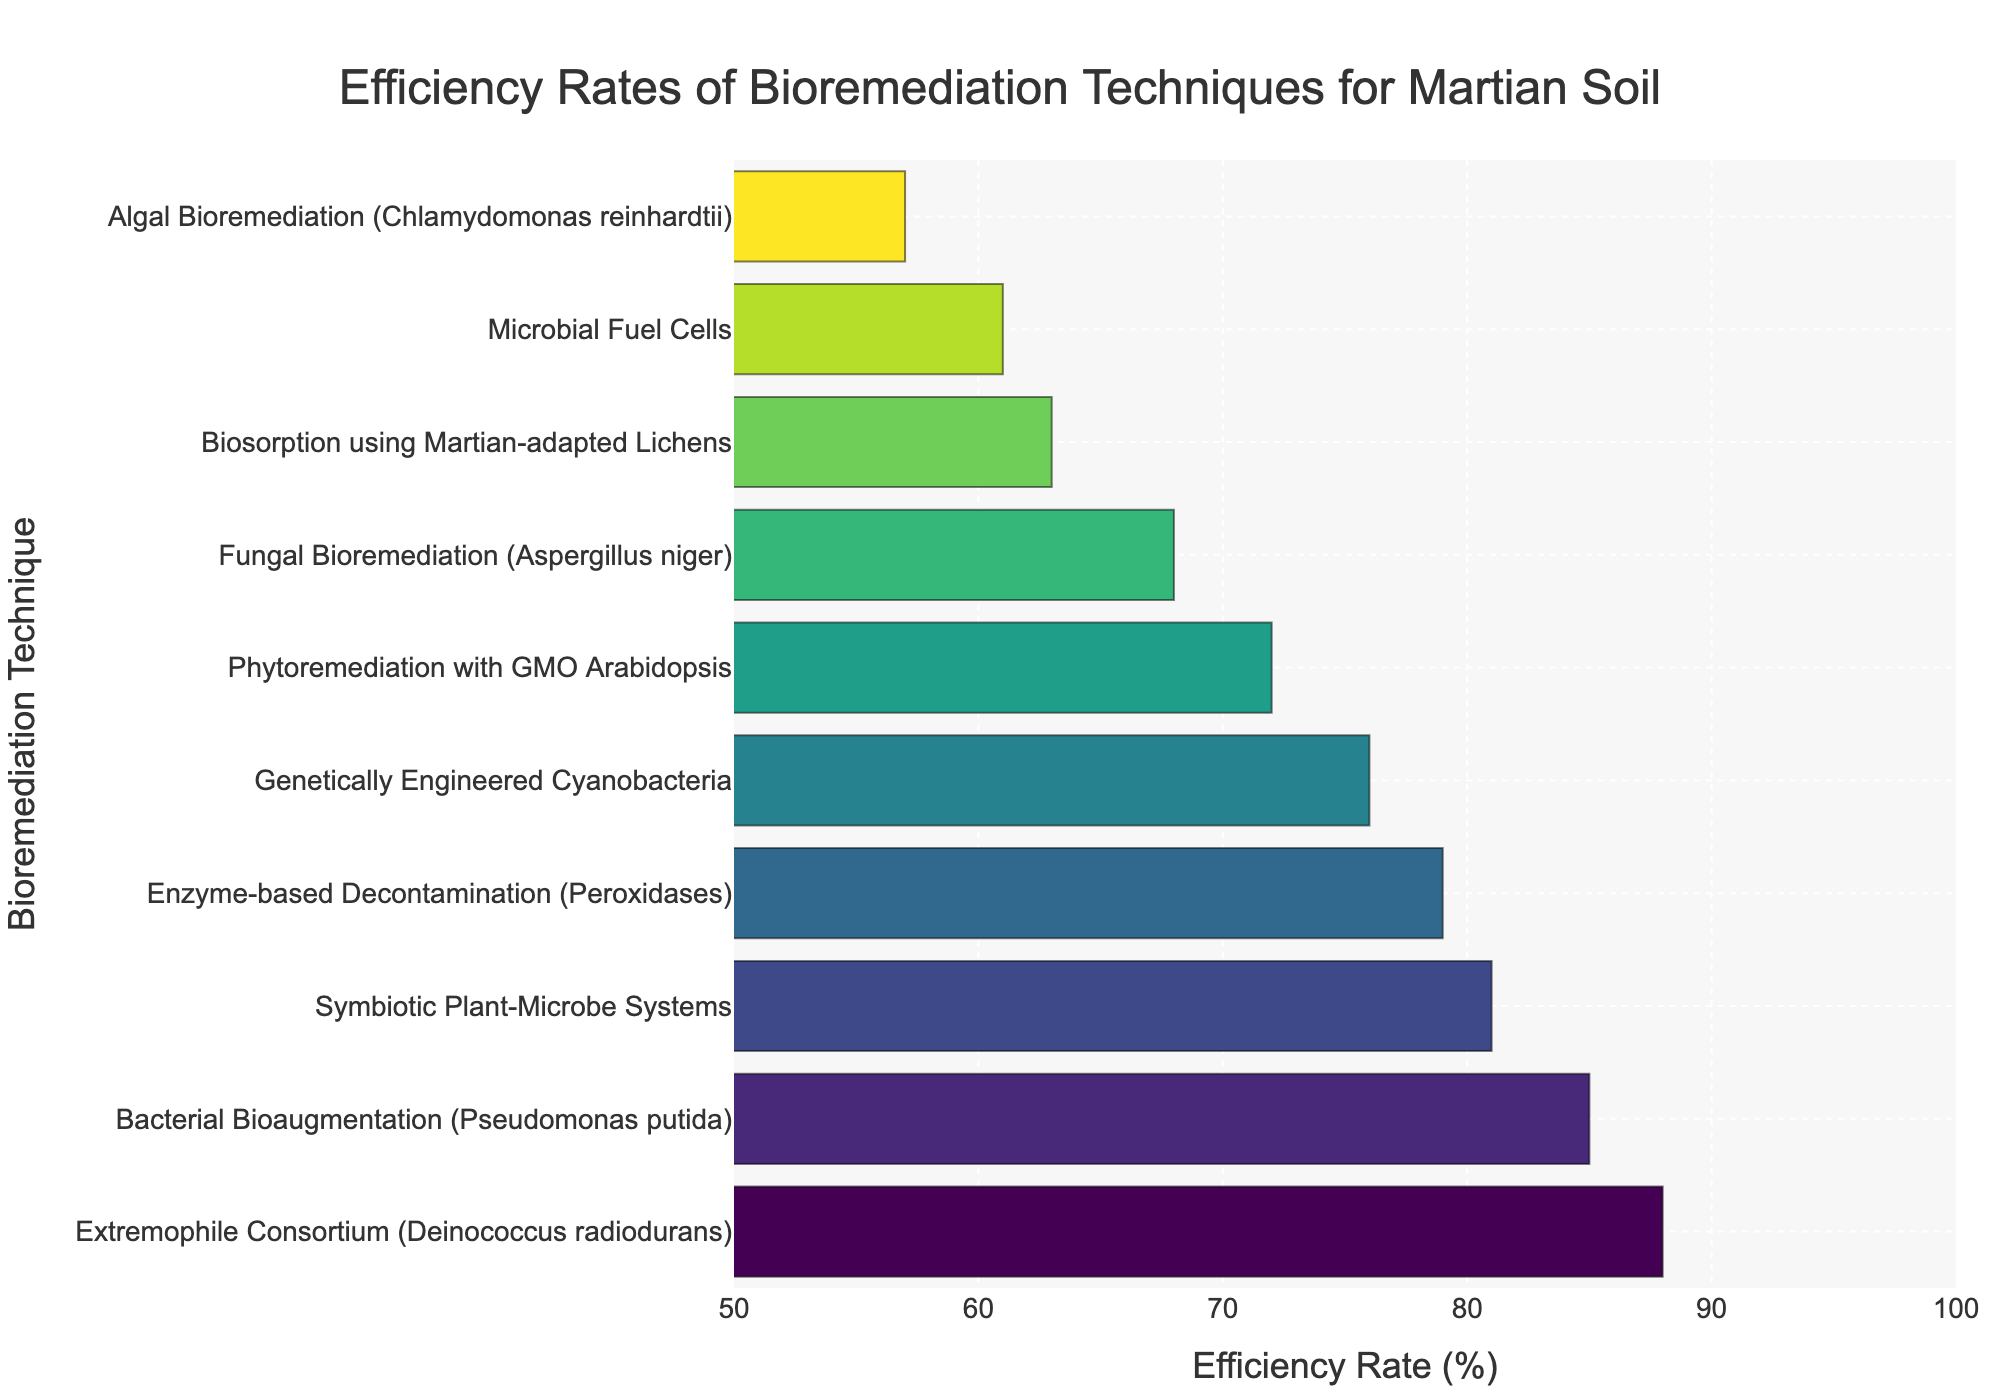What's the highest efficiency rate among the bioremediation techniques? The highest bar on the chart represents the Extremophile Consortium (Deinococcus radiodurans), which has an efficiency rate of 88%. We can clearly see it's the tallest bar, indicating the highest value.
Answer: 88% Which technique has the lowest efficiency rate? The shortest bar on the chart corresponds to Algal Bioremediation (Chlamydomonas reinhardtii), indicating it has the lowest efficiency rate. Looking at the value, we can see it’s 57%.
Answer: Algal Bioremediation (Chlamydomonas reinhardtii) How does the efficiency rate of Bacterial Bioaugmentation (Pseudomonas putida) compare to Enzyme-based Decontamination (Peroxidases)? By comparing the lengths of the respective bars, Bacterial Bioaugmentation (Pseudomonas putida) has a taller bar, indicating it has a higher efficiency (85%) compared to Enzyme-based Decontamination (Peroxidases) which has an efficiency rate of 79%.
Answer: Bacterial Bioaugmentation (Pseudomonas putida) has a higher efficiency rate What's the average efficiency rate of the techniques that have more than 70% efficiency? Techniques with efficiency rates above 70% are Phytoremediation with GMO Arabidopsis (72%), Bacterial Bioaugmentation (85%), Enzyme-based Decontamination (79%), Genetically Engineered Cyanobacteria (76%), Symbiotic Plant-Microbe Systems (81%), and Extremophile Consortium (88%). The average is calculated as:
(72 + 85 + 79 + 76 + 81 + 88) / 6 = 480 / 6 = 80%
Answer: 80% Which technique has an efficiency rate closest to 70% and what is it specifically? Looking at the chart, Phytoremediation with GMO Arabidopsis has an efficiency rate of 72%, which is the closest to 70%. The bar for this technique is just slightly above the 70% mark.
Answer: Phytoremediation with GMO Arabidopsis (72%) How many techniques have an efficiency rate of 75% or higher? The bars showing techniques with efficiency rates of 75% or higher include Bacterial Bioaugmentation (85%), Enzyme-based Decontamination (79%), Genetically Engineered Cyanobacteria (76%), Symbiotic Plant-Microbe Systems (81%), and Extremophile Consortium (88%). In total, there are 5 techniques.
Answer: 5 What's the difference in efficiency rates between the highest and lowest rated techniques? The highest rated technique is Extremophile Consortium (88%) and the lowest is Algal Bioremediation (57%). The difference is calculated as:
88 - 57 = 31%
Answer: 31% Of the techniques listed, which one is directly in the middle efficiency-wise when ordered from highest to lowest? Ordering the techniques from highest to lowest, the middle one is Enzyme-based Decontamination (Peroxidases) with an efficiency rate of 79%. This can be deduced from the sorted bar chart in the middle position.
Answer: Enzyme-based Decontamination (Peroxidases) What is the range of efficiency rates for these bioremediation techniques? The range is the difference between the maximum and minimum efficiency rates observed in the chart. Maximum is 88% (Extremophile Consortium) and the minimum is 57% (Algal Bioremediation). Range is calculated as:
88 - 57 = 31%
Answer: 31% 